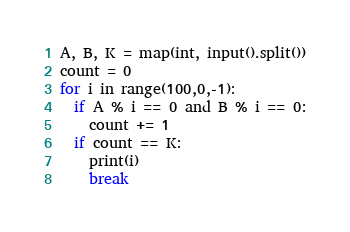Convert code to text. <code><loc_0><loc_0><loc_500><loc_500><_Python_>A, B, K = map(int, input().split())
count = 0
for i in range(100,0,-1):
  if A % i == 0 and B % i == 0:
  	count += 1
  if count == K:
    print(i)
    break
</code> 